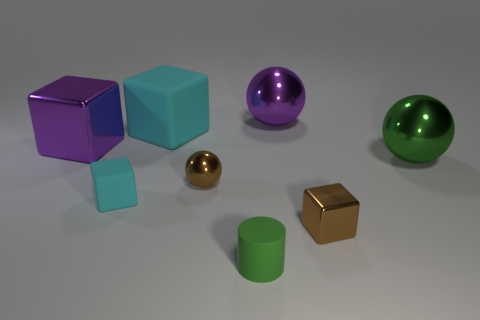Add 1 green metallic objects. How many objects exist? 9 Subtract all cylinders. How many objects are left? 7 Subtract 0 gray cubes. How many objects are left? 8 Subtract all brown metal spheres. Subtract all large cyan matte things. How many objects are left? 6 Add 7 brown shiny spheres. How many brown shiny spheres are left? 8 Add 3 tiny red shiny blocks. How many tiny red shiny blocks exist? 3 